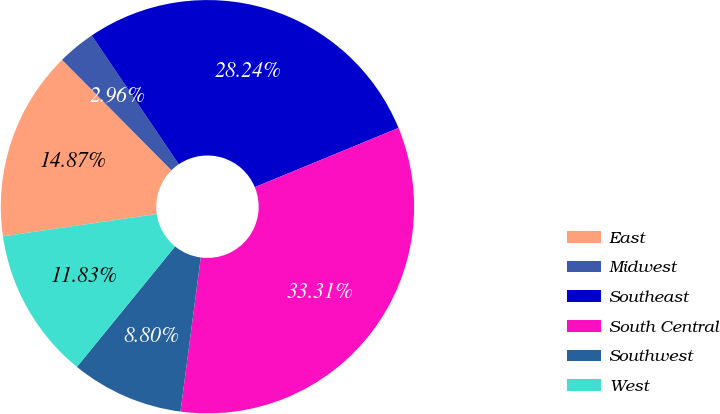Convert chart. <chart><loc_0><loc_0><loc_500><loc_500><pie_chart><fcel>East<fcel>Midwest<fcel>Southeast<fcel>South Central<fcel>Southwest<fcel>West<nl><fcel>14.87%<fcel>2.96%<fcel>28.24%<fcel>33.31%<fcel>8.8%<fcel>11.83%<nl></chart> 